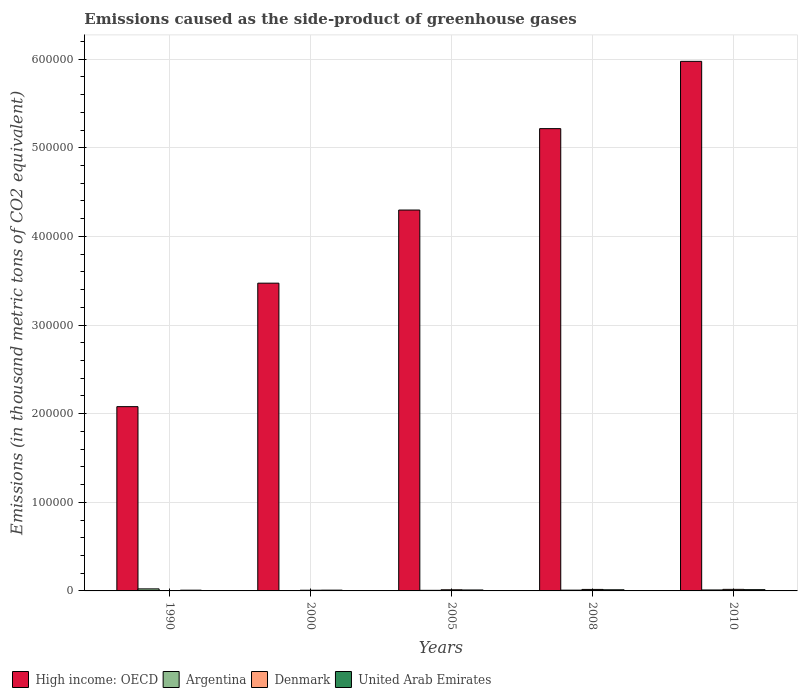How many different coloured bars are there?
Offer a terse response. 4. Are the number of bars per tick equal to the number of legend labels?
Provide a short and direct response. Yes. How many bars are there on the 5th tick from the left?
Make the answer very short. 4. In how many cases, is the number of bars for a given year not equal to the number of legend labels?
Keep it short and to the point. 0. What is the emissions caused as the side-product of greenhouse gases in High income: OECD in 2005?
Ensure brevity in your answer.  4.30e+05. Across all years, what is the maximum emissions caused as the side-product of greenhouse gases in Denmark?
Offer a very short reply. 1750. Across all years, what is the minimum emissions caused as the side-product of greenhouse gases in Denmark?
Offer a very short reply. 88.4. In which year was the emissions caused as the side-product of greenhouse gases in Argentina maximum?
Give a very brief answer. 1990. In which year was the emissions caused as the side-product of greenhouse gases in High income: OECD minimum?
Keep it short and to the point. 1990. What is the total emissions caused as the side-product of greenhouse gases in High income: OECD in the graph?
Ensure brevity in your answer.  2.10e+06. What is the difference between the emissions caused as the side-product of greenhouse gases in United Arab Emirates in 1990 and that in 2010?
Offer a very short reply. -578.6. What is the difference between the emissions caused as the side-product of greenhouse gases in High income: OECD in 2000 and the emissions caused as the side-product of greenhouse gases in United Arab Emirates in 2005?
Your response must be concise. 3.46e+05. What is the average emissions caused as the side-product of greenhouse gases in High income: OECD per year?
Offer a very short reply. 4.21e+05. In the year 2008, what is the difference between the emissions caused as the side-product of greenhouse gases in United Arab Emirates and emissions caused as the side-product of greenhouse gases in Denmark?
Give a very brief answer. -405.5. What is the ratio of the emissions caused as the side-product of greenhouse gases in Denmark in 2000 to that in 2005?
Offer a very short reply. 0.59. Is the emissions caused as the side-product of greenhouse gases in United Arab Emirates in 1990 less than that in 2000?
Your response must be concise. Yes. Is the difference between the emissions caused as the side-product of greenhouse gases in United Arab Emirates in 2000 and 2010 greater than the difference between the emissions caused as the side-product of greenhouse gases in Denmark in 2000 and 2010?
Your response must be concise. Yes. What is the difference between the highest and the second highest emissions caused as the side-product of greenhouse gases in High income: OECD?
Your response must be concise. 7.59e+04. What is the difference between the highest and the lowest emissions caused as the side-product of greenhouse gases in High income: OECD?
Your answer should be very brief. 3.90e+05. In how many years, is the emissions caused as the side-product of greenhouse gases in High income: OECD greater than the average emissions caused as the side-product of greenhouse gases in High income: OECD taken over all years?
Make the answer very short. 3. Is the sum of the emissions caused as the side-product of greenhouse gases in Argentina in 1990 and 2008 greater than the maximum emissions caused as the side-product of greenhouse gases in Denmark across all years?
Keep it short and to the point. Yes. Is it the case that in every year, the sum of the emissions caused as the side-product of greenhouse gases in Argentina and emissions caused as the side-product of greenhouse gases in Denmark is greater than the sum of emissions caused as the side-product of greenhouse gases in United Arab Emirates and emissions caused as the side-product of greenhouse gases in High income: OECD?
Make the answer very short. No. What does the 3rd bar from the right in 2008 represents?
Ensure brevity in your answer.  Argentina. Are all the bars in the graph horizontal?
Ensure brevity in your answer.  No. How many years are there in the graph?
Make the answer very short. 5. What is the difference between two consecutive major ticks on the Y-axis?
Your answer should be compact. 1.00e+05. Are the values on the major ticks of Y-axis written in scientific E-notation?
Make the answer very short. No. Does the graph contain any zero values?
Provide a short and direct response. No. Does the graph contain grids?
Keep it short and to the point. Yes. Where does the legend appear in the graph?
Your answer should be compact. Bottom left. How are the legend labels stacked?
Keep it short and to the point. Horizontal. What is the title of the graph?
Make the answer very short. Emissions caused as the side-product of greenhouse gases. Does "Iran" appear as one of the legend labels in the graph?
Your response must be concise. No. What is the label or title of the Y-axis?
Offer a very short reply. Emissions (in thousand metric tons of CO2 equivalent). What is the Emissions (in thousand metric tons of CO2 equivalent) of High income: OECD in 1990?
Provide a succinct answer. 2.08e+05. What is the Emissions (in thousand metric tons of CO2 equivalent) of Argentina in 1990?
Your answer should be compact. 2296.5. What is the Emissions (in thousand metric tons of CO2 equivalent) in Denmark in 1990?
Give a very brief answer. 88.4. What is the Emissions (in thousand metric tons of CO2 equivalent) in United Arab Emirates in 1990?
Your response must be concise. 843.4. What is the Emissions (in thousand metric tons of CO2 equivalent) in High income: OECD in 2000?
Make the answer very short. 3.47e+05. What is the Emissions (in thousand metric tons of CO2 equivalent) in Argentina in 2000?
Offer a terse response. 408.8. What is the Emissions (in thousand metric tons of CO2 equivalent) in Denmark in 2000?
Provide a short and direct response. 767. What is the Emissions (in thousand metric tons of CO2 equivalent) in United Arab Emirates in 2000?
Offer a terse response. 878.1. What is the Emissions (in thousand metric tons of CO2 equivalent) in High income: OECD in 2005?
Keep it short and to the point. 4.30e+05. What is the Emissions (in thousand metric tons of CO2 equivalent) of Argentina in 2005?
Give a very brief answer. 664.9. What is the Emissions (in thousand metric tons of CO2 equivalent) in Denmark in 2005?
Keep it short and to the point. 1302.5. What is the Emissions (in thousand metric tons of CO2 equivalent) in United Arab Emirates in 2005?
Provide a succinct answer. 1064.1. What is the Emissions (in thousand metric tons of CO2 equivalent) in High income: OECD in 2008?
Offer a very short reply. 5.22e+05. What is the Emissions (in thousand metric tons of CO2 equivalent) of Argentina in 2008?
Your answer should be compact. 872.4. What is the Emissions (in thousand metric tons of CO2 equivalent) of Denmark in 2008?
Your answer should be compact. 1684.5. What is the Emissions (in thousand metric tons of CO2 equivalent) in United Arab Emirates in 2008?
Your answer should be compact. 1279. What is the Emissions (in thousand metric tons of CO2 equivalent) in High income: OECD in 2010?
Keep it short and to the point. 5.97e+05. What is the Emissions (in thousand metric tons of CO2 equivalent) in Argentina in 2010?
Your answer should be very brief. 1084. What is the Emissions (in thousand metric tons of CO2 equivalent) in Denmark in 2010?
Your answer should be compact. 1750. What is the Emissions (in thousand metric tons of CO2 equivalent) in United Arab Emirates in 2010?
Ensure brevity in your answer.  1422. Across all years, what is the maximum Emissions (in thousand metric tons of CO2 equivalent) of High income: OECD?
Your response must be concise. 5.97e+05. Across all years, what is the maximum Emissions (in thousand metric tons of CO2 equivalent) of Argentina?
Your response must be concise. 2296.5. Across all years, what is the maximum Emissions (in thousand metric tons of CO2 equivalent) of Denmark?
Provide a succinct answer. 1750. Across all years, what is the maximum Emissions (in thousand metric tons of CO2 equivalent) in United Arab Emirates?
Give a very brief answer. 1422. Across all years, what is the minimum Emissions (in thousand metric tons of CO2 equivalent) of High income: OECD?
Make the answer very short. 2.08e+05. Across all years, what is the minimum Emissions (in thousand metric tons of CO2 equivalent) of Argentina?
Your response must be concise. 408.8. Across all years, what is the minimum Emissions (in thousand metric tons of CO2 equivalent) of Denmark?
Give a very brief answer. 88.4. Across all years, what is the minimum Emissions (in thousand metric tons of CO2 equivalent) in United Arab Emirates?
Keep it short and to the point. 843.4. What is the total Emissions (in thousand metric tons of CO2 equivalent) of High income: OECD in the graph?
Your answer should be compact. 2.10e+06. What is the total Emissions (in thousand metric tons of CO2 equivalent) of Argentina in the graph?
Offer a terse response. 5326.6. What is the total Emissions (in thousand metric tons of CO2 equivalent) in Denmark in the graph?
Ensure brevity in your answer.  5592.4. What is the total Emissions (in thousand metric tons of CO2 equivalent) of United Arab Emirates in the graph?
Keep it short and to the point. 5486.6. What is the difference between the Emissions (in thousand metric tons of CO2 equivalent) in High income: OECD in 1990 and that in 2000?
Ensure brevity in your answer.  -1.39e+05. What is the difference between the Emissions (in thousand metric tons of CO2 equivalent) of Argentina in 1990 and that in 2000?
Your response must be concise. 1887.7. What is the difference between the Emissions (in thousand metric tons of CO2 equivalent) of Denmark in 1990 and that in 2000?
Provide a short and direct response. -678.6. What is the difference between the Emissions (in thousand metric tons of CO2 equivalent) in United Arab Emirates in 1990 and that in 2000?
Provide a succinct answer. -34.7. What is the difference between the Emissions (in thousand metric tons of CO2 equivalent) in High income: OECD in 1990 and that in 2005?
Give a very brief answer. -2.22e+05. What is the difference between the Emissions (in thousand metric tons of CO2 equivalent) of Argentina in 1990 and that in 2005?
Offer a terse response. 1631.6. What is the difference between the Emissions (in thousand metric tons of CO2 equivalent) in Denmark in 1990 and that in 2005?
Offer a terse response. -1214.1. What is the difference between the Emissions (in thousand metric tons of CO2 equivalent) of United Arab Emirates in 1990 and that in 2005?
Offer a terse response. -220.7. What is the difference between the Emissions (in thousand metric tons of CO2 equivalent) in High income: OECD in 1990 and that in 2008?
Keep it short and to the point. -3.14e+05. What is the difference between the Emissions (in thousand metric tons of CO2 equivalent) in Argentina in 1990 and that in 2008?
Ensure brevity in your answer.  1424.1. What is the difference between the Emissions (in thousand metric tons of CO2 equivalent) in Denmark in 1990 and that in 2008?
Your answer should be very brief. -1596.1. What is the difference between the Emissions (in thousand metric tons of CO2 equivalent) in United Arab Emirates in 1990 and that in 2008?
Offer a very short reply. -435.6. What is the difference between the Emissions (in thousand metric tons of CO2 equivalent) of High income: OECD in 1990 and that in 2010?
Give a very brief answer. -3.90e+05. What is the difference between the Emissions (in thousand metric tons of CO2 equivalent) of Argentina in 1990 and that in 2010?
Offer a terse response. 1212.5. What is the difference between the Emissions (in thousand metric tons of CO2 equivalent) of Denmark in 1990 and that in 2010?
Your answer should be compact. -1661.6. What is the difference between the Emissions (in thousand metric tons of CO2 equivalent) in United Arab Emirates in 1990 and that in 2010?
Your response must be concise. -578.6. What is the difference between the Emissions (in thousand metric tons of CO2 equivalent) of High income: OECD in 2000 and that in 2005?
Offer a terse response. -8.25e+04. What is the difference between the Emissions (in thousand metric tons of CO2 equivalent) in Argentina in 2000 and that in 2005?
Ensure brevity in your answer.  -256.1. What is the difference between the Emissions (in thousand metric tons of CO2 equivalent) in Denmark in 2000 and that in 2005?
Your response must be concise. -535.5. What is the difference between the Emissions (in thousand metric tons of CO2 equivalent) of United Arab Emirates in 2000 and that in 2005?
Provide a succinct answer. -186. What is the difference between the Emissions (in thousand metric tons of CO2 equivalent) in High income: OECD in 2000 and that in 2008?
Ensure brevity in your answer.  -1.74e+05. What is the difference between the Emissions (in thousand metric tons of CO2 equivalent) in Argentina in 2000 and that in 2008?
Offer a terse response. -463.6. What is the difference between the Emissions (in thousand metric tons of CO2 equivalent) in Denmark in 2000 and that in 2008?
Your answer should be compact. -917.5. What is the difference between the Emissions (in thousand metric tons of CO2 equivalent) in United Arab Emirates in 2000 and that in 2008?
Your response must be concise. -400.9. What is the difference between the Emissions (in thousand metric tons of CO2 equivalent) in High income: OECD in 2000 and that in 2010?
Offer a very short reply. -2.50e+05. What is the difference between the Emissions (in thousand metric tons of CO2 equivalent) of Argentina in 2000 and that in 2010?
Make the answer very short. -675.2. What is the difference between the Emissions (in thousand metric tons of CO2 equivalent) in Denmark in 2000 and that in 2010?
Provide a short and direct response. -983. What is the difference between the Emissions (in thousand metric tons of CO2 equivalent) of United Arab Emirates in 2000 and that in 2010?
Offer a very short reply. -543.9. What is the difference between the Emissions (in thousand metric tons of CO2 equivalent) of High income: OECD in 2005 and that in 2008?
Provide a succinct answer. -9.18e+04. What is the difference between the Emissions (in thousand metric tons of CO2 equivalent) of Argentina in 2005 and that in 2008?
Make the answer very short. -207.5. What is the difference between the Emissions (in thousand metric tons of CO2 equivalent) of Denmark in 2005 and that in 2008?
Your answer should be very brief. -382. What is the difference between the Emissions (in thousand metric tons of CO2 equivalent) of United Arab Emirates in 2005 and that in 2008?
Ensure brevity in your answer.  -214.9. What is the difference between the Emissions (in thousand metric tons of CO2 equivalent) in High income: OECD in 2005 and that in 2010?
Ensure brevity in your answer.  -1.68e+05. What is the difference between the Emissions (in thousand metric tons of CO2 equivalent) in Argentina in 2005 and that in 2010?
Provide a succinct answer. -419.1. What is the difference between the Emissions (in thousand metric tons of CO2 equivalent) in Denmark in 2005 and that in 2010?
Your answer should be very brief. -447.5. What is the difference between the Emissions (in thousand metric tons of CO2 equivalent) of United Arab Emirates in 2005 and that in 2010?
Provide a short and direct response. -357.9. What is the difference between the Emissions (in thousand metric tons of CO2 equivalent) in High income: OECD in 2008 and that in 2010?
Offer a terse response. -7.59e+04. What is the difference between the Emissions (in thousand metric tons of CO2 equivalent) in Argentina in 2008 and that in 2010?
Your response must be concise. -211.6. What is the difference between the Emissions (in thousand metric tons of CO2 equivalent) in Denmark in 2008 and that in 2010?
Provide a short and direct response. -65.5. What is the difference between the Emissions (in thousand metric tons of CO2 equivalent) in United Arab Emirates in 2008 and that in 2010?
Provide a short and direct response. -143. What is the difference between the Emissions (in thousand metric tons of CO2 equivalent) of High income: OECD in 1990 and the Emissions (in thousand metric tons of CO2 equivalent) of Argentina in 2000?
Give a very brief answer. 2.07e+05. What is the difference between the Emissions (in thousand metric tons of CO2 equivalent) in High income: OECD in 1990 and the Emissions (in thousand metric tons of CO2 equivalent) in Denmark in 2000?
Offer a very short reply. 2.07e+05. What is the difference between the Emissions (in thousand metric tons of CO2 equivalent) of High income: OECD in 1990 and the Emissions (in thousand metric tons of CO2 equivalent) of United Arab Emirates in 2000?
Your answer should be very brief. 2.07e+05. What is the difference between the Emissions (in thousand metric tons of CO2 equivalent) of Argentina in 1990 and the Emissions (in thousand metric tons of CO2 equivalent) of Denmark in 2000?
Provide a succinct answer. 1529.5. What is the difference between the Emissions (in thousand metric tons of CO2 equivalent) of Argentina in 1990 and the Emissions (in thousand metric tons of CO2 equivalent) of United Arab Emirates in 2000?
Provide a succinct answer. 1418.4. What is the difference between the Emissions (in thousand metric tons of CO2 equivalent) of Denmark in 1990 and the Emissions (in thousand metric tons of CO2 equivalent) of United Arab Emirates in 2000?
Your answer should be compact. -789.7. What is the difference between the Emissions (in thousand metric tons of CO2 equivalent) in High income: OECD in 1990 and the Emissions (in thousand metric tons of CO2 equivalent) in Argentina in 2005?
Provide a short and direct response. 2.07e+05. What is the difference between the Emissions (in thousand metric tons of CO2 equivalent) of High income: OECD in 1990 and the Emissions (in thousand metric tons of CO2 equivalent) of Denmark in 2005?
Provide a succinct answer. 2.07e+05. What is the difference between the Emissions (in thousand metric tons of CO2 equivalent) of High income: OECD in 1990 and the Emissions (in thousand metric tons of CO2 equivalent) of United Arab Emirates in 2005?
Your response must be concise. 2.07e+05. What is the difference between the Emissions (in thousand metric tons of CO2 equivalent) of Argentina in 1990 and the Emissions (in thousand metric tons of CO2 equivalent) of Denmark in 2005?
Ensure brevity in your answer.  994. What is the difference between the Emissions (in thousand metric tons of CO2 equivalent) of Argentina in 1990 and the Emissions (in thousand metric tons of CO2 equivalent) of United Arab Emirates in 2005?
Give a very brief answer. 1232.4. What is the difference between the Emissions (in thousand metric tons of CO2 equivalent) in Denmark in 1990 and the Emissions (in thousand metric tons of CO2 equivalent) in United Arab Emirates in 2005?
Your answer should be compact. -975.7. What is the difference between the Emissions (in thousand metric tons of CO2 equivalent) of High income: OECD in 1990 and the Emissions (in thousand metric tons of CO2 equivalent) of Argentina in 2008?
Keep it short and to the point. 2.07e+05. What is the difference between the Emissions (in thousand metric tons of CO2 equivalent) in High income: OECD in 1990 and the Emissions (in thousand metric tons of CO2 equivalent) in Denmark in 2008?
Give a very brief answer. 2.06e+05. What is the difference between the Emissions (in thousand metric tons of CO2 equivalent) of High income: OECD in 1990 and the Emissions (in thousand metric tons of CO2 equivalent) of United Arab Emirates in 2008?
Your answer should be very brief. 2.07e+05. What is the difference between the Emissions (in thousand metric tons of CO2 equivalent) in Argentina in 1990 and the Emissions (in thousand metric tons of CO2 equivalent) in Denmark in 2008?
Provide a succinct answer. 612. What is the difference between the Emissions (in thousand metric tons of CO2 equivalent) in Argentina in 1990 and the Emissions (in thousand metric tons of CO2 equivalent) in United Arab Emirates in 2008?
Your answer should be compact. 1017.5. What is the difference between the Emissions (in thousand metric tons of CO2 equivalent) in Denmark in 1990 and the Emissions (in thousand metric tons of CO2 equivalent) in United Arab Emirates in 2008?
Offer a terse response. -1190.6. What is the difference between the Emissions (in thousand metric tons of CO2 equivalent) of High income: OECD in 1990 and the Emissions (in thousand metric tons of CO2 equivalent) of Argentina in 2010?
Provide a succinct answer. 2.07e+05. What is the difference between the Emissions (in thousand metric tons of CO2 equivalent) of High income: OECD in 1990 and the Emissions (in thousand metric tons of CO2 equivalent) of Denmark in 2010?
Keep it short and to the point. 2.06e+05. What is the difference between the Emissions (in thousand metric tons of CO2 equivalent) in High income: OECD in 1990 and the Emissions (in thousand metric tons of CO2 equivalent) in United Arab Emirates in 2010?
Your response must be concise. 2.06e+05. What is the difference between the Emissions (in thousand metric tons of CO2 equivalent) in Argentina in 1990 and the Emissions (in thousand metric tons of CO2 equivalent) in Denmark in 2010?
Keep it short and to the point. 546.5. What is the difference between the Emissions (in thousand metric tons of CO2 equivalent) in Argentina in 1990 and the Emissions (in thousand metric tons of CO2 equivalent) in United Arab Emirates in 2010?
Make the answer very short. 874.5. What is the difference between the Emissions (in thousand metric tons of CO2 equivalent) of Denmark in 1990 and the Emissions (in thousand metric tons of CO2 equivalent) of United Arab Emirates in 2010?
Make the answer very short. -1333.6. What is the difference between the Emissions (in thousand metric tons of CO2 equivalent) in High income: OECD in 2000 and the Emissions (in thousand metric tons of CO2 equivalent) in Argentina in 2005?
Your response must be concise. 3.47e+05. What is the difference between the Emissions (in thousand metric tons of CO2 equivalent) of High income: OECD in 2000 and the Emissions (in thousand metric tons of CO2 equivalent) of Denmark in 2005?
Ensure brevity in your answer.  3.46e+05. What is the difference between the Emissions (in thousand metric tons of CO2 equivalent) of High income: OECD in 2000 and the Emissions (in thousand metric tons of CO2 equivalent) of United Arab Emirates in 2005?
Provide a succinct answer. 3.46e+05. What is the difference between the Emissions (in thousand metric tons of CO2 equivalent) in Argentina in 2000 and the Emissions (in thousand metric tons of CO2 equivalent) in Denmark in 2005?
Your answer should be very brief. -893.7. What is the difference between the Emissions (in thousand metric tons of CO2 equivalent) in Argentina in 2000 and the Emissions (in thousand metric tons of CO2 equivalent) in United Arab Emirates in 2005?
Keep it short and to the point. -655.3. What is the difference between the Emissions (in thousand metric tons of CO2 equivalent) in Denmark in 2000 and the Emissions (in thousand metric tons of CO2 equivalent) in United Arab Emirates in 2005?
Provide a short and direct response. -297.1. What is the difference between the Emissions (in thousand metric tons of CO2 equivalent) in High income: OECD in 2000 and the Emissions (in thousand metric tons of CO2 equivalent) in Argentina in 2008?
Offer a very short reply. 3.46e+05. What is the difference between the Emissions (in thousand metric tons of CO2 equivalent) in High income: OECD in 2000 and the Emissions (in thousand metric tons of CO2 equivalent) in Denmark in 2008?
Your answer should be very brief. 3.46e+05. What is the difference between the Emissions (in thousand metric tons of CO2 equivalent) in High income: OECD in 2000 and the Emissions (in thousand metric tons of CO2 equivalent) in United Arab Emirates in 2008?
Offer a terse response. 3.46e+05. What is the difference between the Emissions (in thousand metric tons of CO2 equivalent) in Argentina in 2000 and the Emissions (in thousand metric tons of CO2 equivalent) in Denmark in 2008?
Your answer should be very brief. -1275.7. What is the difference between the Emissions (in thousand metric tons of CO2 equivalent) in Argentina in 2000 and the Emissions (in thousand metric tons of CO2 equivalent) in United Arab Emirates in 2008?
Offer a very short reply. -870.2. What is the difference between the Emissions (in thousand metric tons of CO2 equivalent) in Denmark in 2000 and the Emissions (in thousand metric tons of CO2 equivalent) in United Arab Emirates in 2008?
Your answer should be very brief. -512. What is the difference between the Emissions (in thousand metric tons of CO2 equivalent) of High income: OECD in 2000 and the Emissions (in thousand metric tons of CO2 equivalent) of Argentina in 2010?
Ensure brevity in your answer.  3.46e+05. What is the difference between the Emissions (in thousand metric tons of CO2 equivalent) of High income: OECD in 2000 and the Emissions (in thousand metric tons of CO2 equivalent) of Denmark in 2010?
Your response must be concise. 3.45e+05. What is the difference between the Emissions (in thousand metric tons of CO2 equivalent) of High income: OECD in 2000 and the Emissions (in thousand metric tons of CO2 equivalent) of United Arab Emirates in 2010?
Give a very brief answer. 3.46e+05. What is the difference between the Emissions (in thousand metric tons of CO2 equivalent) in Argentina in 2000 and the Emissions (in thousand metric tons of CO2 equivalent) in Denmark in 2010?
Make the answer very short. -1341.2. What is the difference between the Emissions (in thousand metric tons of CO2 equivalent) of Argentina in 2000 and the Emissions (in thousand metric tons of CO2 equivalent) of United Arab Emirates in 2010?
Provide a succinct answer. -1013.2. What is the difference between the Emissions (in thousand metric tons of CO2 equivalent) in Denmark in 2000 and the Emissions (in thousand metric tons of CO2 equivalent) in United Arab Emirates in 2010?
Offer a terse response. -655. What is the difference between the Emissions (in thousand metric tons of CO2 equivalent) of High income: OECD in 2005 and the Emissions (in thousand metric tons of CO2 equivalent) of Argentina in 2008?
Your answer should be compact. 4.29e+05. What is the difference between the Emissions (in thousand metric tons of CO2 equivalent) in High income: OECD in 2005 and the Emissions (in thousand metric tons of CO2 equivalent) in Denmark in 2008?
Your response must be concise. 4.28e+05. What is the difference between the Emissions (in thousand metric tons of CO2 equivalent) in High income: OECD in 2005 and the Emissions (in thousand metric tons of CO2 equivalent) in United Arab Emirates in 2008?
Keep it short and to the point. 4.28e+05. What is the difference between the Emissions (in thousand metric tons of CO2 equivalent) of Argentina in 2005 and the Emissions (in thousand metric tons of CO2 equivalent) of Denmark in 2008?
Offer a terse response. -1019.6. What is the difference between the Emissions (in thousand metric tons of CO2 equivalent) in Argentina in 2005 and the Emissions (in thousand metric tons of CO2 equivalent) in United Arab Emirates in 2008?
Keep it short and to the point. -614.1. What is the difference between the Emissions (in thousand metric tons of CO2 equivalent) in Denmark in 2005 and the Emissions (in thousand metric tons of CO2 equivalent) in United Arab Emirates in 2008?
Provide a succinct answer. 23.5. What is the difference between the Emissions (in thousand metric tons of CO2 equivalent) in High income: OECD in 2005 and the Emissions (in thousand metric tons of CO2 equivalent) in Argentina in 2010?
Provide a succinct answer. 4.29e+05. What is the difference between the Emissions (in thousand metric tons of CO2 equivalent) of High income: OECD in 2005 and the Emissions (in thousand metric tons of CO2 equivalent) of Denmark in 2010?
Give a very brief answer. 4.28e+05. What is the difference between the Emissions (in thousand metric tons of CO2 equivalent) in High income: OECD in 2005 and the Emissions (in thousand metric tons of CO2 equivalent) in United Arab Emirates in 2010?
Make the answer very short. 4.28e+05. What is the difference between the Emissions (in thousand metric tons of CO2 equivalent) in Argentina in 2005 and the Emissions (in thousand metric tons of CO2 equivalent) in Denmark in 2010?
Your answer should be very brief. -1085.1. What is the difference between the Emissions (in thousand metric tons of CO2 equivalent) in Argentina in 2005 and the Emissions (in thousand metric tons of CO2 equivalent) in United Arab Emirates in 2010?
Make the answer very short. -757.1. What is the difference between the Emissions (in thousand metric tons of CO2 equivalent) in Denmark in 2005 and the Emissions (in thousand metric tons of CO2 equivalent) in United Arab Emirates in 2010?
Your answer should be compact. -119.5. What is the difference between the Emissions (in thousand metric tons of CO2 equivalent) in High income: OECD in 2008 and the Emissions (in thousand metric tons of CO2 equivalent) in Argentina in 2010?
Offer a terse response. 5.20e+05. What is the difference between the Emissions (in thousand metric tons of CO2 equivalent) in High income: OECD in 2008 and the Emissions (in thousand metric tons of CO2 equivalent) in Denmark in 2010?
Make the answer very short. 5.20e+05. What is the difference between the Emissions (in thousand metric tons of CO2 equivalent) in High income: OECD in 2008 and the Emissions (in thousand metric tons of CO2 equivalent) in United Arab Emirates in 2010?
Your response must be concise. 5.20e+05. What is the difference between the Emissions (in thousand metric tons of CO2 equivalent) of Argentina in 2008 and the Emissions (in thousand metric tons of CO2 equivalent) of Denmark in 2010?
Your answer should be compact. -877.6. What is the difference between the Emissions (in thousand metric tons of CO2 equivalent) of Argentina in 2008 and the Emissions (in thousand metric tons of CO2 equivalent) of United Arab Emirates in 2010?
Your response must be concise. -549.6. What is the difference between the Emissions (in thousand metric tons of CO2 equivalent) of Denmark in 2008 and the Emissions (in thousand metric tons of CO2 equivalent) of United Arab Emirates in 2010?
Offer a terse response. 262.5. What is the average Emissions (in thousand metric tons of CO2 equivalent) in High income: OECD per year?
Offer a terse response. 4.21e+05. What is the average Emissions (in thousand metric tons of CO2 equivalent) in Argentina per year?
Ensure brevity in your answer.  1065.32. What is the average Emissions (in thousand metric tons of CO2 equivalent) in Denmark per year?
Offer a terse response. 1118.48. What is the average Emissions (in thousand metric tons of CO2 equivalent) in United Arab Emirates per year?
Provide a succinct answer. 1097.32. In the year 1990, what is the difference between the Emissions (in thousand metric tons of CO2 equivalent) of High income: OECD and Emissions (in thousand metric tons of CO2 equivalent) of Argentina?
Offer a terse response. 2.06e+05. In the year 1990, what is the difference between the Emissions (in thousand metric tons of CO2 equivalent) of High income: OECD and Emissions (in thousand metric tons of CO2 equivalent) of Denmark?
Your answer should be compact. 2.08e+05. In the year 1990, what is the difference between the Emissions (in thousand metric tons of CO2 equivalent) in High income: OECD and Emissions (in thousand metric tons of CO2 equivalent) in United Arab Emirates?
Keep it short and to the point. 2.07e+05. In the year 1990, what is the difference between the Emissions (in thousand metric tons of CO2 equivalent) in Argentina and Emissions (in thousand metric tons of CO2 equivalent) in Denmark?
Your answer should be very brief. 2208.1. In the year 1990, what is the difference between the Emissions (in thousand metric tons of CO2 equivalent) in Argentina and Emissions (in thousand metric tons of CO2 equivalent) in United Arab Emirates?
Provide a short and direct response. 1453.1. In the year 1990, what is the difference between the Emissions (in thousand metric tons of CO2 equivalent) in Denmark and Emissions (in thousand metric tons of CO2 equivalent) in United Arab Emirates?
Your response must be concise. -755. In the year 2000, what is the difference between the Emissions (in thousand metric tons of CO2 equivalent) of High income: OECD and Emissions (in thousand metric tons of CO2 equivalent) of Argentina?
Your response must be concise. 3.47e+05. In the year 2000, what is the difference between the Emissions (in thousand metric tons of CO2 equivalent) in High income: OECD and Emissions (in thousand metric tons of CO2 equivalent) in Denmark?
Ensure brevity in your answer.  3.46e+05. In the year 2000, what is the difference between the Emissions (in thousand metric tons of CO2 equivalent) in High income: OECD and Emissions (in thousand metric tons of CO2 equivalent) in United Arab Emirates?
Your answer should be compact. 3.46e+05. In the year 2000, what is the difference between the Emissions (in thousand metric tons of CO2 equivalent) of Argentina and Emissions (in thousand metric tons of CO2 equivalent) of Denmark?
Ensure brevity in your answer.  -358.2. In the year 2000, what is the difference between the Emissions (in thousand metric tons of CO2 equivalent) in Argentina and Emissions (in thousand metric tons of CO2 equivalent) in United Arab Emirates?
Offer a terse response. -469.3. In the year 2000, what is the difference between the Emissions (in thousand metric tons of CO2 equivalent) in Denmark and Emissions (in thousand metric tons of CO2 equivalent) in United Arab Emirates?
Provide a succinct answer. -111.1. In the year 2005, what is the difference between the Emissions (in thousand metric tons of CO2 equivalent) of High income: OECD and Emissions (in thousand metric tons of CO2 equivalent) of Argentina?
Give a very brief answer. 4.29e+05. In the year 2005, what is the difference between the Emissions (in thousand metric tons of CO2 equivalent) of High income: OECD and Emissions (in thousand metric tons of CO2 equivalent) of Denmark?
Keep it short and to the point. 4.28e+05. In the year 2005, what is the difference between the Emissions (in thousand metric tons of CO2 equivalent) of High income: OECD and Emissions (in thousand metric tons of CO2 equivalent) of United Arab Emirates?
Give a very brief answer. 4.29e+05. In the year 2005, what is the difference between the Emissions (in thousand metric tons of CO2 equivalent) in Argentina and Emissions (in thousand metric tons of CO2 equivalent) in Denmark?
Ensure brevity in your answer.  -637.6. In the year 2005, what is the difference between the Emissions (in thousand metric tons of CO2 equivalent) in Argentina and Emissions (in thousand metric tons of CO2 equivalent) in United Arab Emirates?
Provide a short and direct response. -399.2. In the year 2005, what is the difference between the Emissions (in thousand metric tons of CO2 equivalent) of Denmark and Emissions (in thousand metric tons of CO2 equivalent) of United Arab Emirates?
Provide a short and direct response. 238.4. In the year 2008, what is the difference between the Emissions (in thousand metric tons of CO2 equivalent) in High income: OECD and Emissions (in thousand metric tons of CO2 equivalent) in Argentina?
Keep it short and to the point. 5.21e+05. In the year 2008, what is the difference between the Emissions (in thousand metric tons of CO2 equivalent) of High income: OECD and Emissions (in thousand metric tons of CO2 equivalent) of Denmark?
Give a very brief answer. 5.20e+05. In the year 2008, what is the difference between the Emissions (in thousand metric tons of CO2 equivalent) in High income: OECD and Emissions (in thousand metric tons of CO2 equivalent) in United Arab Emirates?
Offer a very short reply. 5.20e+05. In the year 2008, what is the difference between the Emissions (in thousand metric tons of CO2 equivalent) of Argentina and Emissions (in thousand metric tons of CO2 equivalent) of Denmark?
Your answer should be very brief. -812.1. In the year 2008, what is the difference between the Emissions (in thousand metric tons of CO2 equivalent) in Argentina and Emissions (in thousand metric tons of CO2 equivalent) in United Arab Emirates?
Offer a terse response. -406.6. In the year 2008, what is the difference between the Emissions (in thousand metric tons of CO2 equivalent) of Denmark and Emissions (in thousand metric tons of CO2 equivalent) of United Arab Emirates?
Ensure brevity in your answer.  405.5. In the year 2010, what is the difference between the Emissions (in thousand metric tons of CO2 equivalent) of High income: OECD and Emissions (in thousand metric tons of CO2 equivalent) of Argentina?
Offer a terse response. 5.96e+05. In the year 2010, what is the difference between the Emissions (in thousand metric tons of CO2 equivalent) in High income: OECD and Emissions (in thousand metric tons of CO2 equivalent) in Denmark?
Give a very brief answer. 5.96e+05. In the year 2010, what is the difference between the Emissions (in thousand metric tons of CO2 equivalent) of High income: OECD and Emissions (in thousand metric tons of CO2 equivalent) of United Arab Emirates?
Give a very brief answer. 5.96e+05. In the year 2010, what is the difference between the Emissions (in thousand metric tons of CO2 equivalent) in Argentina and Emissions (in thousand metric tons of CO2 equivalent) in Denmark?
Provide a short and direct response. -666. In the year 2010, what is the difference between the Emissions (in thousand metric tons of CO2 equivalent) of Argentina and Emissions (in thousand metric tons of CO2 equivalent) of United Arab Emirates?
Ensure brevity in your answer.  -338. In the year 2010, what is the difference between the Emissions (in thousand metric tons of CO2 equivalent) of Denmark and Emissions (in thousand metric tons of CO2 equivalent) of United Arab Emirates?
Make the answer very short. 328. What is the ratio of the Emissions (in thousand metric tons of CO2 equivalent) in High income: OECD in 1990 to that in 2000?
Your answer should be compact. 0.6. What is the ratio of the Emissions (in thousand metric tons of CO2 equivalent) in Argentina in 1990 to that in 2000?
Your response must be concise. 5.62. What is the ratio of the Emissions (in thousand metric tons of CO2 equivalent) in Denmark in 1990 to that in 2000?
Make the answer very short. 0.12. What is the ratio of the Emissions (in thousand metric tons of CO2 equivalent) in United Arab Emirates in 1990 to that in 2000?
Offer a terse response. 0.96. What is the ratio of the Emissions (in thousand metric tons of CO2 equivalent) in High income: OECD in 1990 to that in 2005?
Your response must be concise. 0.48. What is the ratio of the Emissions (in thousand metric tons of CO2 equivalent) in Argentina in 1990 to that in 2005?
Provide a short and direct response. 3.45. What is the ratio of the Emissions (in thousand metric tons of CO2 equivalent) in Denmark in 1990 to that in 2005?
Your answer should be very brief. 0.07. What is the ratio of the Emissions (in thousand metric tons of CO2 equivalent) of United Arab Emirates in 1990 to that in 2005?
Ensure brevity in your answer.  0.79. What is the ratio of the Emissions (in thousand metric tons of CO2 equivalent) in High income: OECD in 1990 to that in 2008?
Make the answer very short. 0.4. What is the ratio of the Emissions (in thousand metric tons of CO2 equivalent) of Argentina in 1990 to that in 2008?
Keep it short and to the point. 2.63. What is the ratio of the Emissions (in thousand metric tons of CO2 equivalent) of Denmark in 1990 to that in 2008?
Your answer should be compact. 0.05. What is the ratio of the Emissions (in thousand metric tons of CO2 equivalent) in United Arab Emirates in 1990 to that in 2008?
Your answer should be compact. 0.66. What is the ratio of the Emissions (in thousand metric tons of CO2 equivalent) of High income: OECD in 1990 to that in 2010?
Offer a terse response. 0.35. What is the ratio of the Emissions (in thousand metric tons of CO2 equivalent) of Argentina in 1990 to that in 2010?
Provide a short and direct response. 2.12. What is the ratio of the Emissions (in thousand metric tons of CO2 equivalent) in Denmark in 1990 to that in 2010?
Your answer should be very brief. 0.05. What is the ratio of the Emissions (in thousand metric tons of CO2 equivalent) in United Arab Emirates in 1990 to that in 2010?
Offer a terse response. 0.59. What is the ratio of the Emissions (in thousand metric tons of CO2 equivalent) of High income: OECD in 2000 to that in 2005?
Make the answer very short. 0.81. What is the ratio of the Emissions (in thousand metric tons of CO2 equivalent) in Argentina in 2000 to that in 2005?
Give a very brief answer. 0.61. What is the ratio of the Emissions (in thousand metric tons of CO2 equivalent) in Denmark in 2000 to that in 2005?
Keep it short and to the point. 0.59. What is the ratio of the Emissions (in thousand metric tons of CO2 equivalent) in United Arab Emirates in 2000 to that in 2005?
Offer a terse response. 0.83. What is the ratio of the Emissions (in thousand metric tons of CO2 equivalent) in High income: OECD in 2000 to that in 2008?
Provide a succinct answer. 0.67. What is the ratio of the Emissions (in thousand metric tons of CO2 equivalent) in Argentina in 2000 to that in 2008?
Offer a very short reply. 0.47. What is the ratio of the Emissions (in thousand metric tons of CO2 equivalent) of Denmark in 2000 to that in 2008?
Provide a succinct answer. 0.46. What is the ratio of the Emissions (in thousand metric tons of CO2 equivalent) of United Arab Emirates in 2000 to that in 2008?
Provide a short and direct response. 0.69. What is the ratio of the Emissions (in thousand metric tons of CO2 equivalent) in High income: OECD in 2000 to that in 2010?
Your answer should be very brief. 0.58. What is the ratio of the Emissions (in thousand metric tons of CO2 equivalent) of Argentina in 2000 to that in 2010?
Your answer should be very brief. 0.38. What is the ratio of the Emissions (in thousand metric tons of CO2 equivalent) in Denmark in 2000 to that in 2010?
Give a very brief answer. 0.44. What is the ratio of the Emissions (in thousand metric tons of CO2 equivalent) in United Arab Emirates in 2000 to that in 2010?
Provide a short and direct response. 0.62. What is the ratio of the Emissions (in thousand metric tons of CO2 equivalent) of High income: OECD in 2005 to that in 2008?
Provide a short and direct response. 0.82. What is the ratio of the Emissions (in thousand metric tons of CO2 equivalent) of Argentina in 2005 to that in 2008?
Offer a very short reply. 0.76. What is the ratio of the Emissions (in thousand metric tons of CO2 equivalent) of Denmark in 2005 to that in 2008?
Give a very brief answer. 0.77. What is the ratio of the Emissions (in thousand metric tons of CO2 equivalent) in United Arab Emirates in 2005 to that in 2008?
Your answer should be very brief. 0.83. What is the ratio of the Emissions (in thousand metric tons of CO2 equivalent) in High income: OECD in 2005 to that in 2010?
Keep it short and to the point. 0.72. What is the ratio of the Emissions (in thousand metric tons of CO2 equivalent) in Argentina in 2005 to that in 2010?
Your response must be concise. 0.61. What is the ratio of the Emissions (in thousand metric tons of CO2 equivalent) of Denmark in 2005 to that in 2010?
Make the answer very short. 0.74. What is the ratio of the Emissions (in thousand metric tons of CO2 equivalent) of United Arab Emirates in 2005 to that in 2010?
Ensure brevity in your answer.  0.75. What is the ratio of the Emissions (in thousand metric tons of CO2 equivalent) in High income: OECD in 2008 to that in 2010?
Keep it short and to the point. 0.87. What is the ratio of the Emissions (in thousand metric tons of CO2 equivalent) in Argentina in 2008 to that in 2010?
Your answer should be compact. 0.8. What is the ratio of the Emissions (in thousand metric tons of CO2 equivalent) of Denmark in 2008 to that in 2010?
Give a very brief answer. 0.96. What is the ratio of the Emissions (in thousand metric tons of CO2 equivalent) in United Arab Emirates in 2008 to that in 2010?
Keep it short and to the point. 0.9. What is the difference between the highest and the second highest Emissions (in thousand metric tons of CO2 equivalent) in High income: OECD?
Your answer should be very brief. 7.59e+04. What is the difference between the highest and the second highest Emissions (in thousand metric tons of CO2 equivalent) in Argentina?
Provide a succinct answer. 1212.5. What is the difference between the highest and the second highest Emissions (in thousand metric tons of CO2 equivalent) of Denmark?
Give a very brief answer. 65.5. What is the difference between the highest and the second highest Emissions (in thousand metric tons of CO2 equivalent) of United Arab Emirates?
Make the answer very short. 143. What is the difference between the highest and the lowest Emissions (in thousand metric tons of CO2 equivalent) in High income: OECD?
Ensure brevity in your answer.  3.90e+05. What is the difference between the highest and the lowest Emissions (in thousand metric tons of CO2 equivalent) in Argentina?
Provide a succinct answer. 1887.7. What is the difference between the highest and the lowest Emissions (in thousand metric tons of CO2 equivalent) of Denmark?
Give a very brief answer. 1661.6. What is the difference between the highest and the lowest Emissions (in thousand metric tons of CO2 equivalent) in United Arab Emirates?
Make the answer very short. 578.6. 